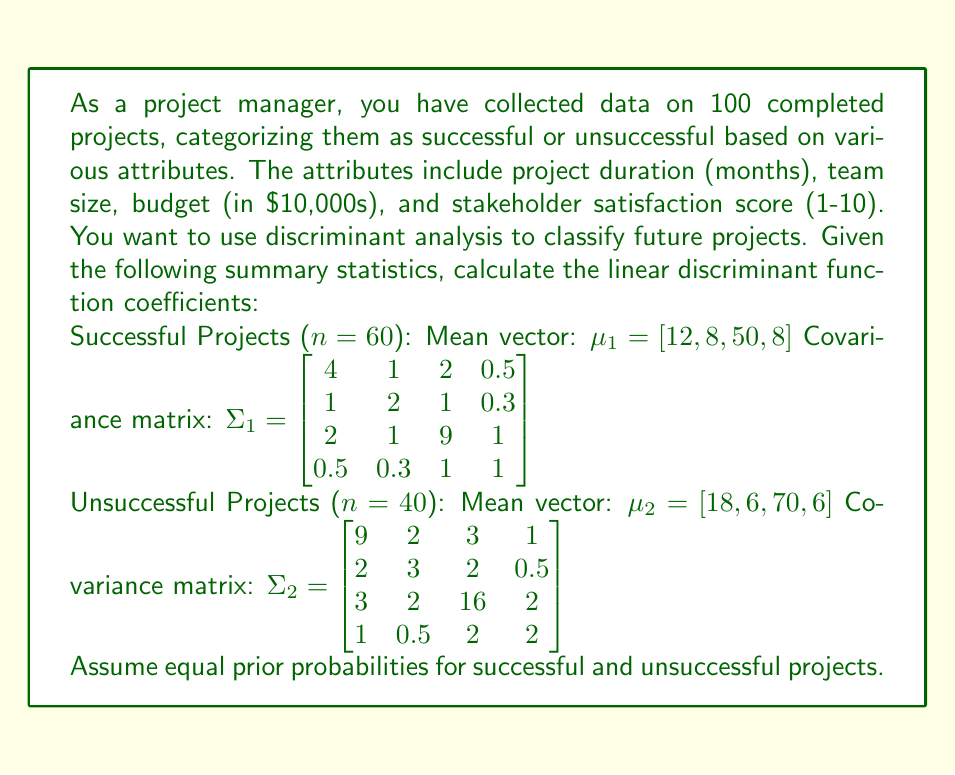Could you help me with this problem? To calculate the linear discriminant function coefficients, we'll follow these steps:

1. Calculate the pooled covariance matrix $\Sigma$:
   $$\Sigma = \frac{(n_1 - 1)\Sigma_1 + (n_2 - 1)\Sigma_2}{n_1 + n_2 - 2}$$

   $$\Sigma = \frac{59\Sigma_1 + 39\Sigma_2}{98}$$

2. Calculate $\Sigma^{-1}(\mu_1 - \mu_2)$, which gives us the direction of the linear discriminant function.

3. The constant term is calculated as $-\frac{1}{2}(\mu_1 + \mu_2)^T \Sigma^{-1}(\mu_1 - \mu_2)$.

Step 1: Calculating the pooled covariance matrix $\Sigma$

$$\Sigma = \frac{59\begin{bmatrix}
4 & 1 & 2 & 0.5 \\
1 & 2 & 1 & 0.3 \\
2 & 1 & 9 & 1 \\
0.5 & 0.3 & 1 & 1
\end{bmatrix} + 39\begin{bmatrix}
9 & 2 & 3 & 1 \\
2 & 3 & 2 & 0.5 \\
3 & 2 & 16 & 2 \\
1 & 0.5 & 2 & 2
\end{bmatrix}}{98}$$

$$\Sigma = \begin{bmatrix}
6.0204 & 1.4082 & 2.4286 & 0.7041 \\
1.4082 & 2.4082 & 1.4082 & 0.3776 \\
2.4286 & 1.4082 & 11.8163 & 1.4082 \\
0.7041 & 0.3776 & 1.4082 & 1.4082
\end{bmatrix}$$

Step 2: Calculating $\Sigma^{-1}(\mu_1 - \mu_2)$

First, we need to find $\Sigma^{-1}$:

$$\Sigma^{-1} = \begin{bmatrix}
0.1913 & -0.0986 & -0.0328 & -0.0657 \\
-0.0986 & 0.4755 & -0.0219 & -0.0438 \\
-0.0328 & -0.0219 & 0.0986 & -0.0438 \\
-0.0657 & -0.0438 & -0.0438 & 0.7847
\end{bmatrix}$$

Now, we calculate $\mu_1 - \mu_2$:

$$\mu_1 - \mu_2 = [12, 8, 50, 8] - [18, 6, 70, 6] = [-6, 2, -20, 2]$$

Then, we multiply $\Sigma^{-1}$ by $(\mu_1 - \mu_2)$:

$$\Sigma^{-1}(\mu_1 - \mu_2) = \begin{bmatrix}
-0.3942 \\
0.8942 \\
-1.9726 \\
1.3066
\end{bmatrix}$$

Step 3: Calculating the constant term

$$-\frac{1}{2}(\mu_1 + \mu_2)^T \Sigma^{-1}(\mu_1 - \mu_2)$$

$$(\mu_1 + \mu_2) = [30, 14, 120, 14]$$

$$-\frac{1}{2}[30, 14, 120, 14] \begin{bmatrix}
-0.3942 \\
0.8942 \\
-1.9726 \\
1.3066
\end{bmatrix} = 106.9790$$

The linear discriminant function is:

$$f(x) = -0.3942x_1 + 0.8942x_2 - 1.9726x_3 + 1.3066x_4 + 106.9790$$

where $x_1$ is project duration, $x_2$ is team size, $x_3$ is budget, and $x_4$ is stakeholder satisfaction score.
Answer: The linear discriminant function coefficients are:
Project duration: -0.3942
Team size: 0.8942
Budget: -1.9726
Stakeholder satisfaction score: 1.3066
Constant term: 106.9790 